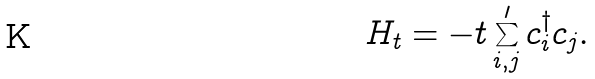Convert formula to latex. <formula><loc_0><loc_0><loc_500><loc_500>H _ { t } = - t \sum _ { i , j } ^ { \prime } c _ { i } ^ { \dag } c _ { j } .</formula> 